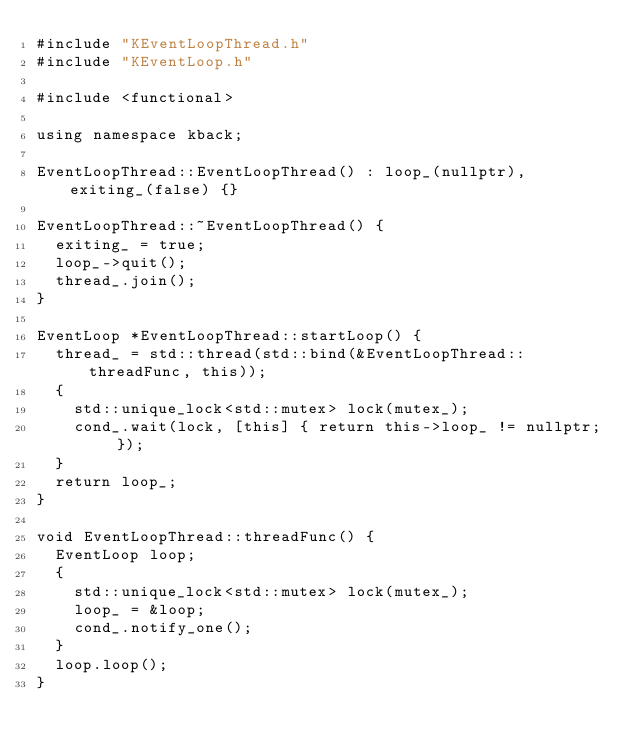Convert code to text. <code><loc_0><loc_0><loc_500><loc_500><_C++_>#include "KEventLoopThread.h"
#include "KEventLoop.h"

#include <functional>

using namespace kback;

EventLoopThread::EventLoopThread() : loop_(nullptr), exiting_(false) {}

EventLoopThread::~EventLoopThread() {
  exiting_ = true;
  loop_->quit();
  thread_.join();
}

EventLoop *EventLoopThread::startLoop() {
  thread_ = std::thread(std::bind(&EventLoopThread::threadFunc, this));
  {
    std::unique_lock<std::mutex> lock(mutex_);
    cond_.wait(lock, [this] { return this->loop_ != nullptr; });
  }
  return loop_;
}

void EventLoopThread::threadFunc() {
  EventLoop loop;
  {
    std::unique_lock<std::mutex> lock(mutex_);
    loop_ = &loop;
    cond_.notify_one();
  }
  loop.loop();
}</code> 